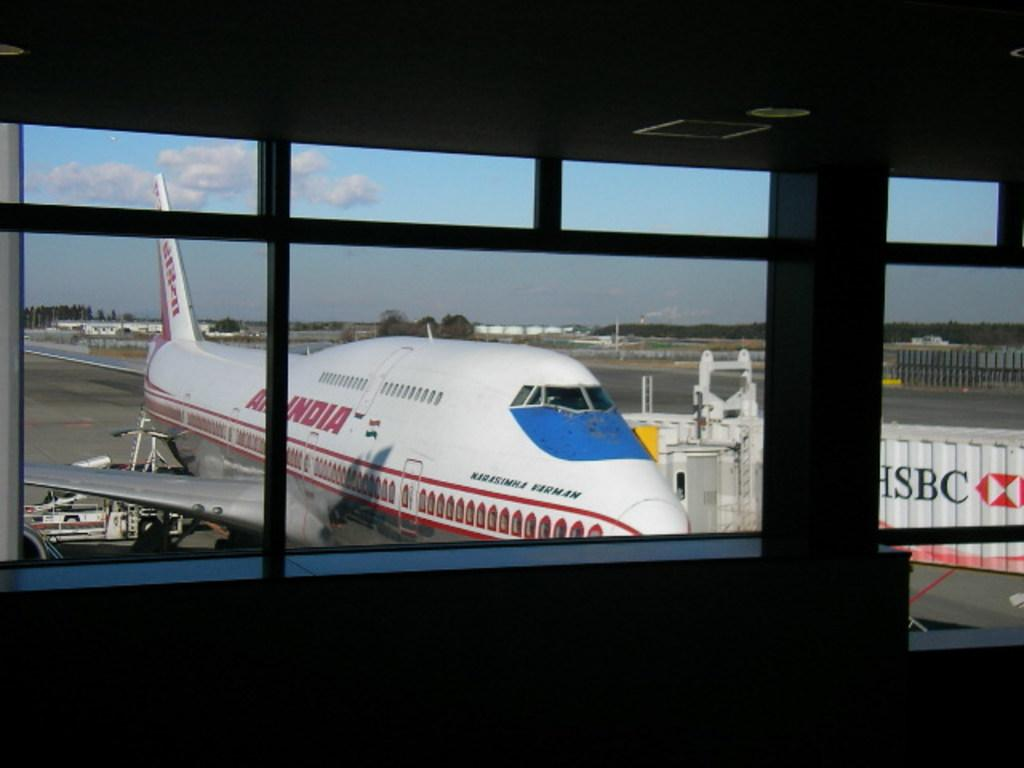<image>
Describe the image concisely. A white and red plane has India painted on the side. 